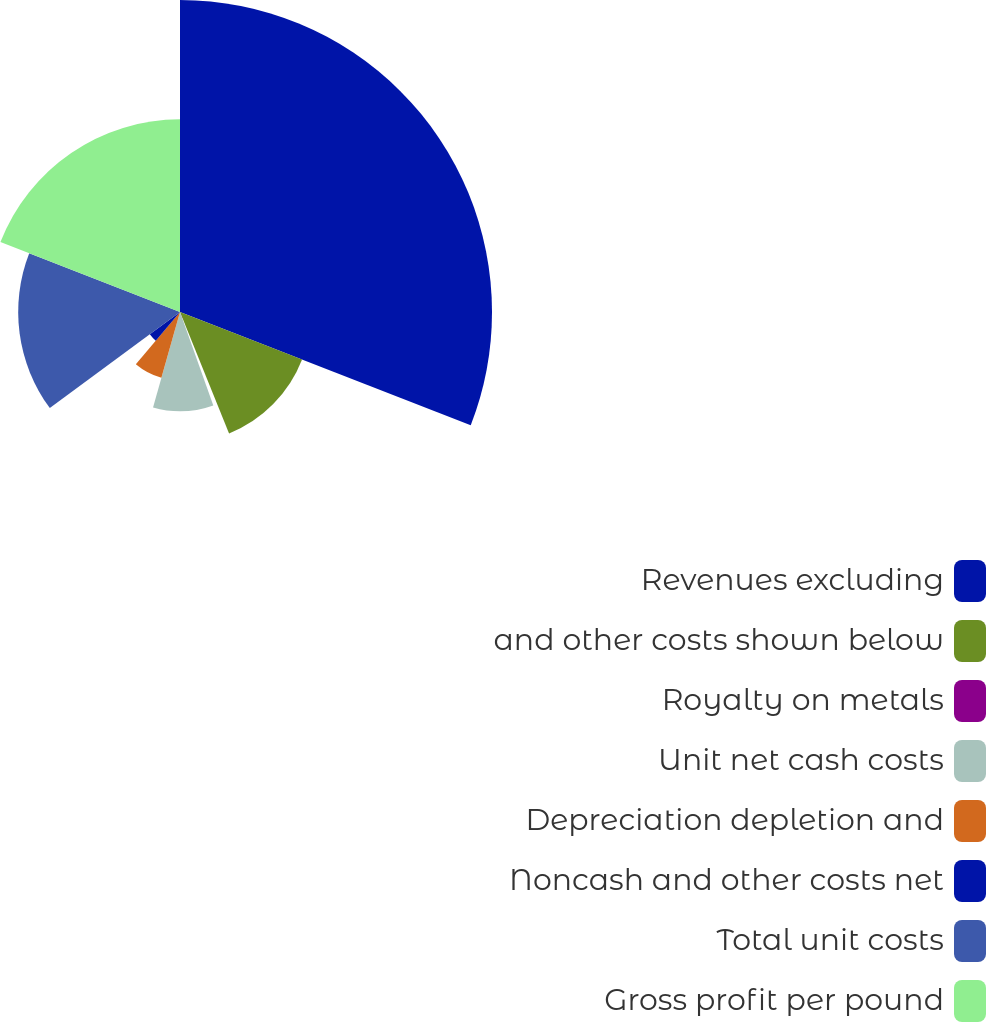Convert chart. <chart><loc_0><loc_0><loc_500><loc_500><pie_chart><fcel>Revenues excluding<fcel>and other costs shown below<fcel>Royalty on metals<fcel>Unit net cash costs<fcel>Depreciation depletion and<fcel>Noncash and other costs net<fcel>Total unit costs<fcel>Gross profit per pound<nl><fcel>30.91%<fcel>12.98%<fcel>0.66%<fcel>9.83%<fcel>6.78%<fcel>3.72%<fcel>16.03%<fcel>19.09%<nl></chart> 